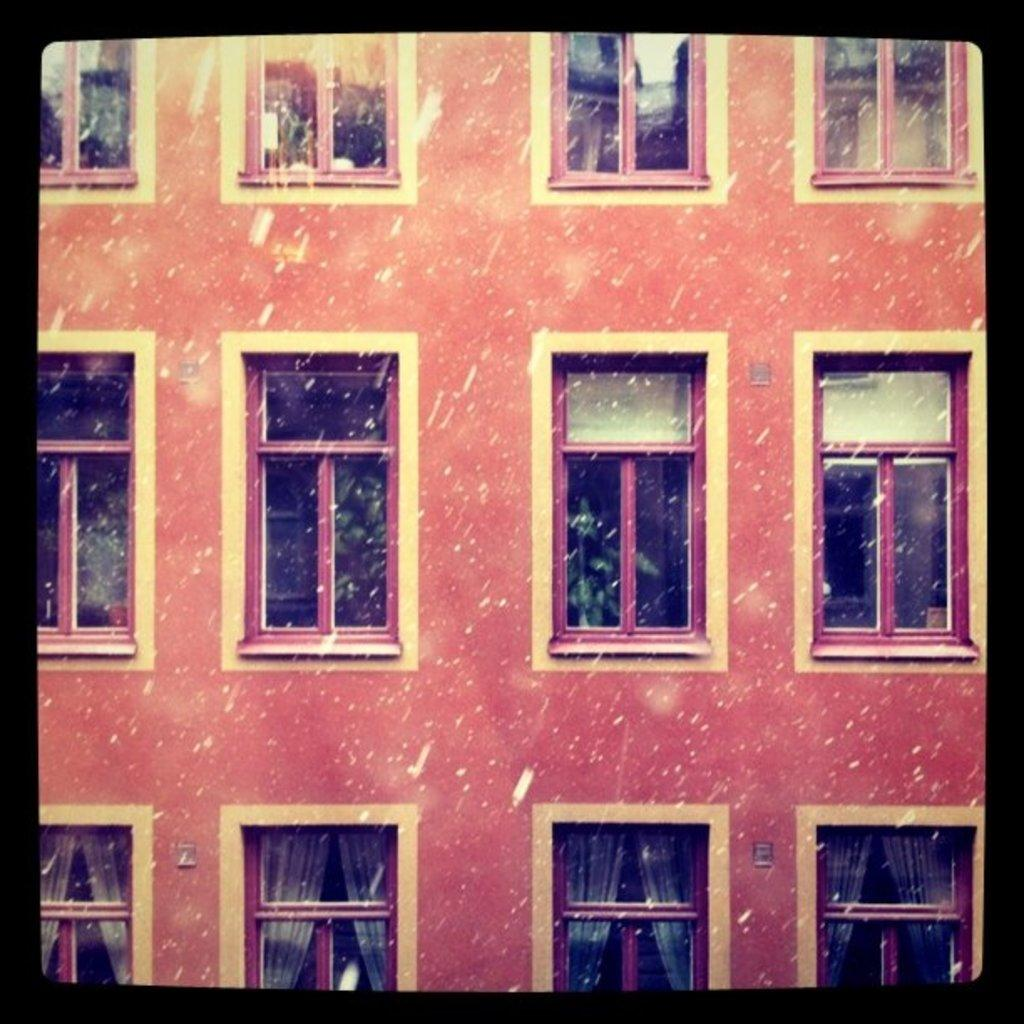What type of image is being described? The image is an edited image. What can be seen in the image besides the editing effects? There is a part of a building in the image. What architectural feature is prominent in the building? There are many windows in the building. What can be seen behind the windows? Curtains are visible behind the windows. What type of stamp can be seen on the tongue of the person in the image? There is no person present in the image, and therefore no tongue or stamp. 